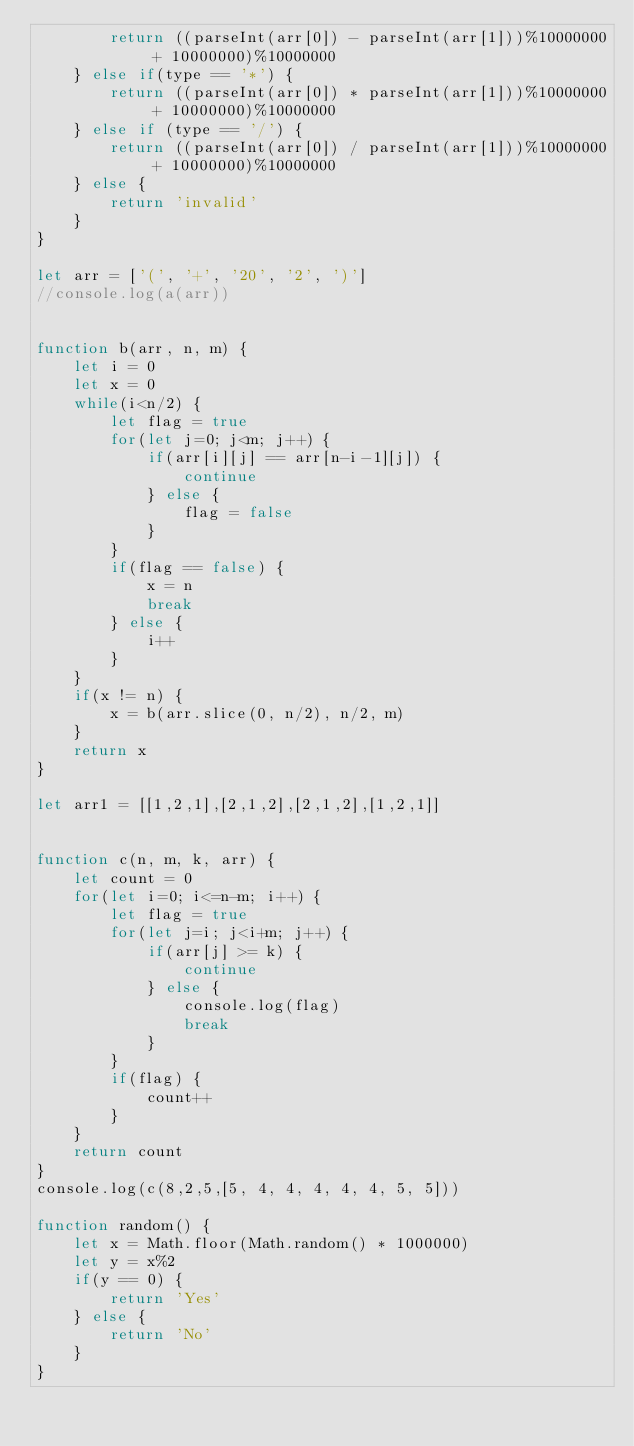<code> <loc_0><loc_0><loc_500><loc_500><_JavaScript_>        return ((parseInt(arr[0]) - parseInt(arr[1]))%10000000 + 10000000)%10000000
    } else if(type == '*') {
        return ((parseInt(arr[0]) * parseInt(arr[1]))%10000000 + 10000000)%10000000
    } else if (type == '/') {
        return ((parseInt(arr[0]) / parseInt(arr[1]))%10000000 + 10000000)%10000000
    } else {
        return 'invalid'
    }
}

let arr = ['(', '+', '20', '2', ')']
//console.log(a(arr))


function b(arr, n, m) {
    let i = 0
    let x = 0
    while(i<n/2) {
        let flag = true
        for(let j=0; j<m; j++) {
            if(arr[i][j] == arr[n-i-1][j]) {
                continue
            } else {
                flag = false
            }
        }
        if(flag == false) {
            x = n
            break
        } else {
            i++
        }
    }
    if(x != n) {
        x = b(arr.slice(0, n/2), n/2, m)
    }
    return x
}

let arr1 = [[1,2,1],[2,1,2],[2,1,2],[1,2,1]]


function c(n, m, k, arr) {
    let count = 0
    for(let i=0; i<=n-m; i++) {
        let flag = true
        for(let j=i; j<i+m; j++) {
            if(arr[j] >= k) {
                continue
            } else {
                console.log(flag)
                break
            }
        }
        if(flag) {
            count++
        }
    }
    return count
}
console.log(c(8,2,5,[5, 4, 4, 4, 4, 4, 5, 5]))

function random() {
    let x = Math.floor(Math.random() * 1000000)
    let y = x%2
    if(y == 0) {
        return 'Yes'
    } else {
        return 'No'
    }
}</code> 